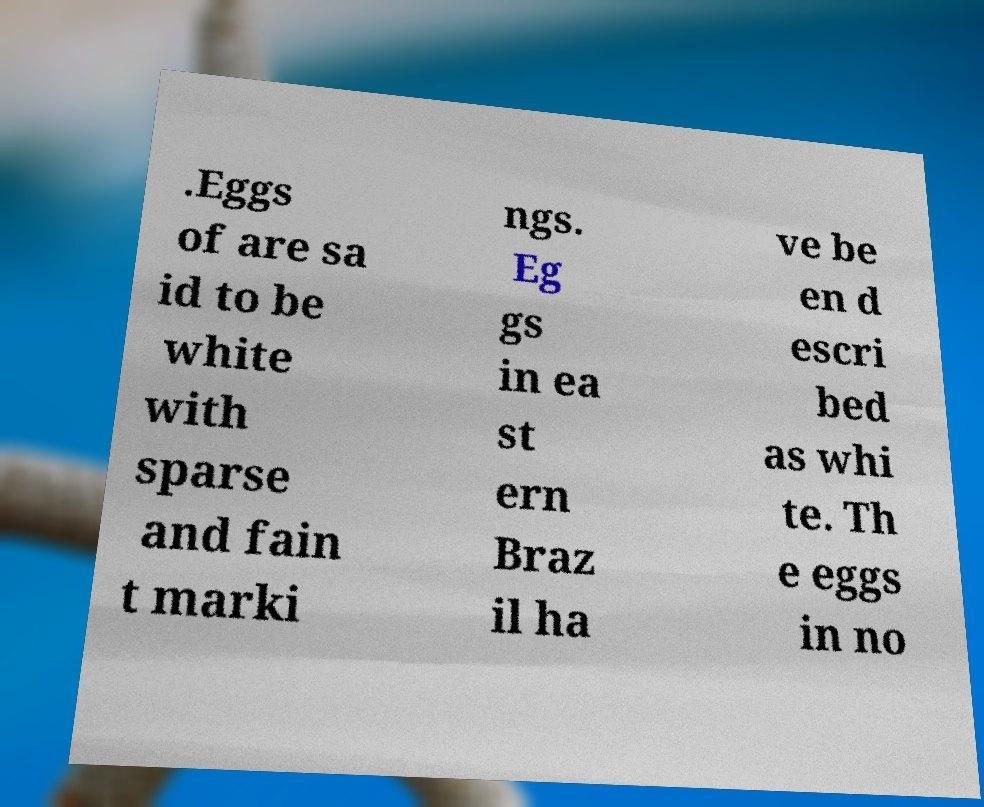For documentation purposes, I need the text within this image transcribed. Could you provide that? .Eggs of are sa id to be white with sparse and fain t marki ngs. Eg gs in ea st ern Braz il ha ve be en d escri bed as whi te. Th e eggs in no 